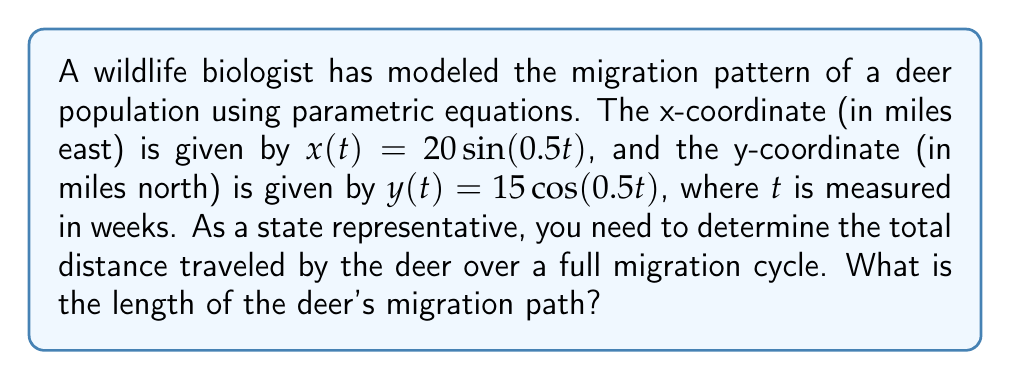Can you answer this question? To find the length of the migration path, we need to follow these steps:

1) The migration pattern forms an ellipse. To find its circumference, we can use the approximate formula:

   $C \approx 2\pi\sqrt{\frac{a^2 + b^2}{2}}$

   where $a$ and $b$ are the semi-major and semi-minor axes.

2) From the given equations, we can see that $a = 20$ and $b = 15$.

3) Let's substitute these values into the formula:

   $C \approx 2\pi\sqrt{\frac{20^2 + 15^2}{2}}$

4) Simplify inside the square root:
   
   $C \approx 2\pi\sqrt{\frac{400 + 225}{2}} = 2\pi\sqrt{\frac{625}{2}}$

5) Simplify further:

   $C \approx 2\pi\sqrt{312.5} \approx 2\pi(17.68) \approx 111.0$

6) Therefore, the approximate length of the migration path is 111.0 miles.
Answer: 111.0 miles 